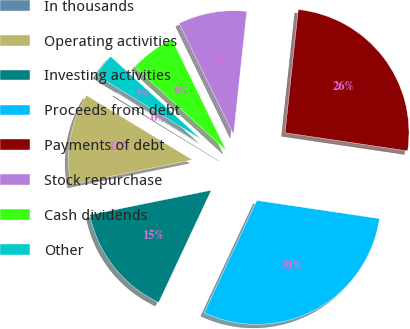Convert chart to OTSL. <chart><loc_0><loc_0><loc_500><loc_500><pie_chart><fcel>In thousands<fcel>Operating activities<fcel>Investing activities<fcel>Proceeds from debt<fcel>Payments of debt<fcel>Stock repurchase<fcel>Cash dividends<fcel>Other<nl><fcel>0.06%<fcel>11.89%<fcel>14.85%<fcel>29.63%<fcel>25.64%<fcel>8.93%<fcel>5.98%<fcel>3.02%<nl></chart> 